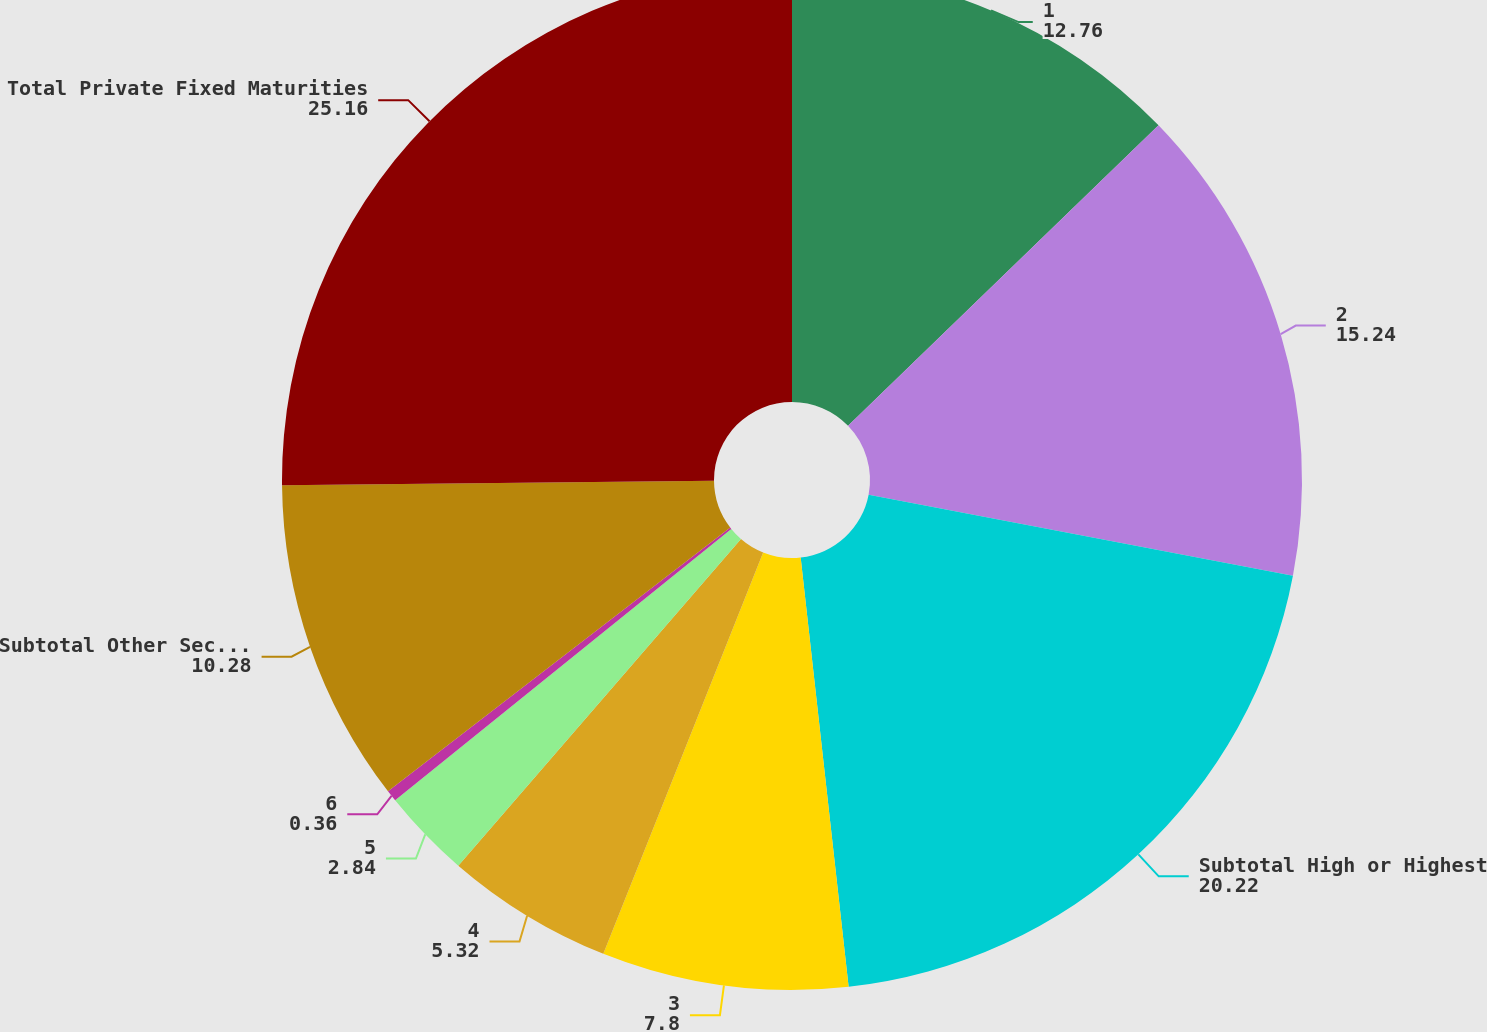Convert chart to OTSL. <chart><loc_0><loc_0><loc_500><loc_500><pie_chart><fcel>1<fcel>2<fcel>Subtotal High or Highest<fcel>3<fcel>4<fcel>5<fcel>6<fcel>Subtotal Other Securities(4)<fcel>Total Private Fixed Maturities<nl><fcel>12.76%<fcel>15.24%<fcel>20.22%<fcel>7.8%<fcel>5.32%<fcel>2.84%<fcel>0.36%<fcel>10.28%<fcel>25.16%<nl></chart> 